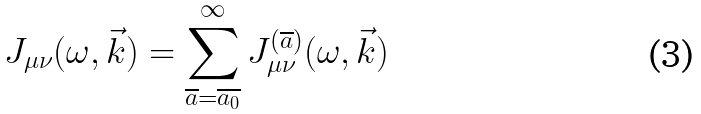<formula> <loc_0><loc_0><loc_500><loc_500>J _ { \mu \nu } ( \omega , \vec { k } ) = \sum _ { \overline { a } = \overline { a _ { 0 } } } ^ { \infty } J _ { \mu \nu } ^ { ( \overline { a } ) } ( \omega , \vec { k } )</formula> 